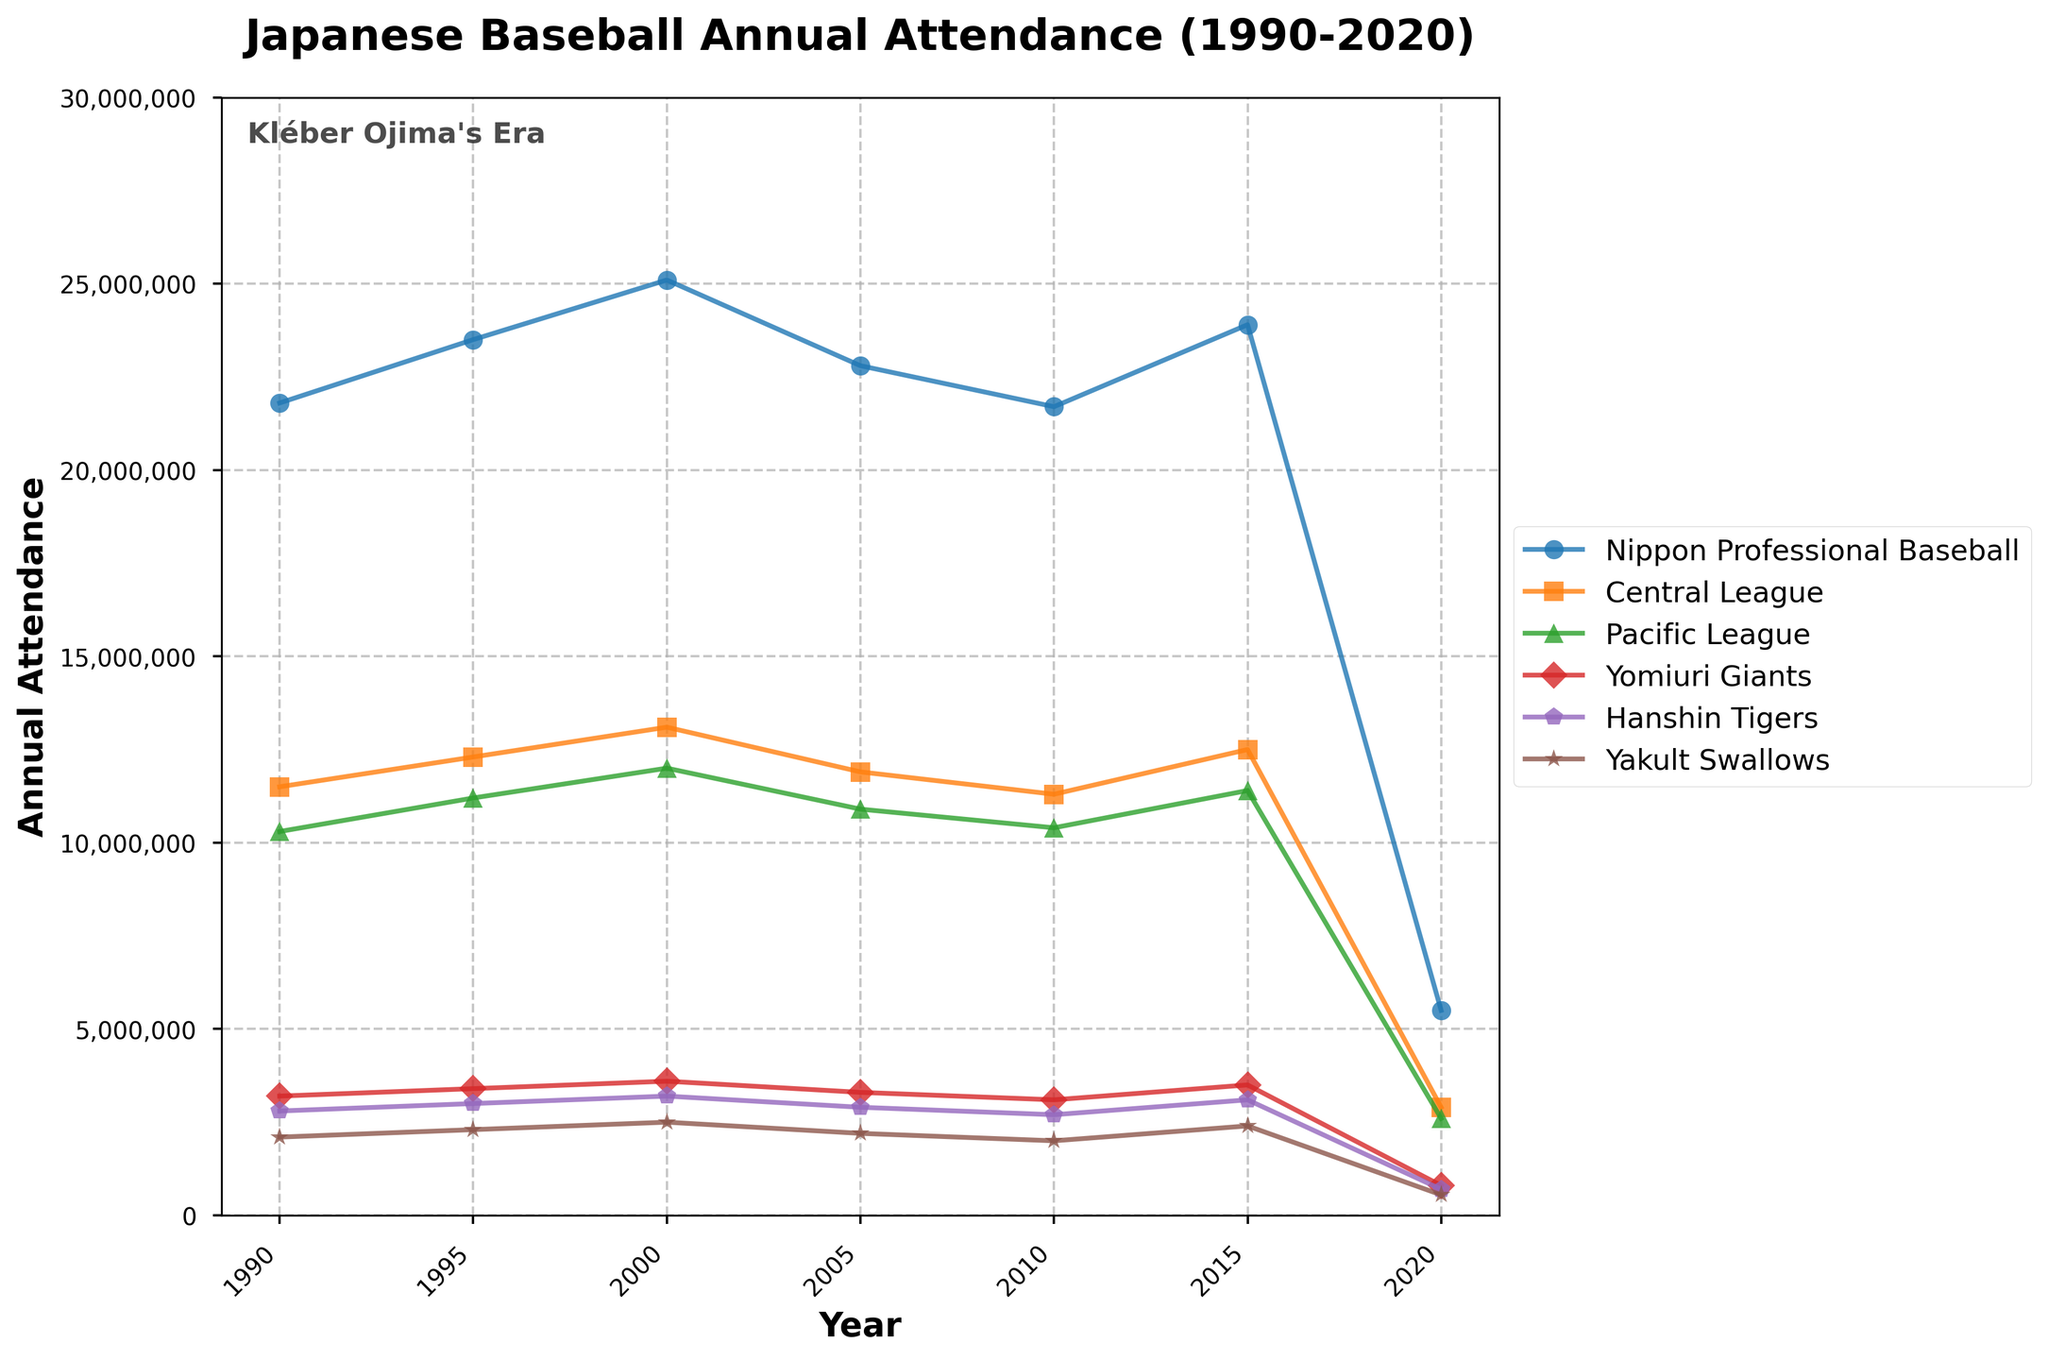What's the total attendance for Nippon Professional Baseball in the years 2000 and 2005 combined? The attendance for Nippon Professional Baseball in 2000 is 25,100,000, and in 2005 it is 22,800,000. Summing these values gives 25,100,000 + 22,800,000 = 47,900,000
Answer: 47,900,000 Which league had a higher attendance in 2010, the Central or the Pacific League? The attendance for the Central League in 2010 is 11,300,000, and for the Pacific League it is 10,400,000. Comparing these values, the Central League had a higher attendance.
Answer: Central League By how much did the attendance for the Yomiuri Giants decrease from 1995 to 2020? The attendance for the Yomiuri Giants in 1995 is 3,400,000, and in 2020 it is 800,000. The decrease is calculated as 3,400,000 - 800,000 = 2,600,000
Answer: 2,600,000 What was the average annual attendance for the Hanshin Tigers from 1990 to 2020? To find the average, sum the Hanshin Tigers' attendance for the given years and divide by the number of years. Total attendance: 2,800,000 (1990) + 3,000,000 (1995) + 3,200,000 (2000) + 2,900,000 (2005) + 2,700,000 (2010) + 3,100,000 (2015) + 700,000 (2020) = 18,400,000. Number of years = 7. Average = 18,400,000 / 7 = 2,628,571
Answer: 2,628,571 Which team had the lowest attendance in the year 2020? In 2020, the attendance figures are Yomiuri Giants: 800,000, Hanshin Tigers: 700,000, Yakult Swallows: 550,000. The Yakult Swallows had the lowest attendance.
Answer: Yakult Swallows Which year saw the highest total attendance for Nippon Professional Baseball? Review the attendance figures for Nippon Professional Baseball from 1990 to 2020. The highest attendance is 25,100,000 in the year 2000.
Answer: 2000 How did the annual attendance for the Yakult Swallows change between 1990 and 2015? In 1990, the Yakult Swallows' attendance was 2,100,000, and in 2015 it was 2,400,000. The change is 2,400,000 - 2,100,000 = 300,000
Answer: Increased by 300,000 Compare the attendance trends for Nippon Professional Baseball and the Central League from 1990 to 2020. Are there any notable similarities or differences? From the data: Both Nippon Professional Baseball and the Central League show an overall increasing trend from 1990 to 2000, a decrease from 2000 to 2005, another decrease to 2010, and a rise again to 2015. Both figures substantially drop by 2020. The patterns are quite similar, indicating that Central League attendance closely follows the overall Nippon Professional Baseball trend.
Answer: Similar trends What is the difference in attendance between the Central League and the Pacific League in the year 1990? In 1990, the Central League's attendance was 11,500,000, and the Pacific League's attendance was 10,300,000. The difference is 11,500,000 - 10,300,000 = 1,200,000
Answer: 1,200,000 Was the total attendance for all leagues higher in 2015 or 2000? Total attendance for 2000 = 25,100,000 (Nippon Professional Baseball). Total attendance for 2015 = 23,900,000 (Nippon Professional Baseball). Comparing these two values, the total attendance in 2000 was higher.
Answer: 2000 